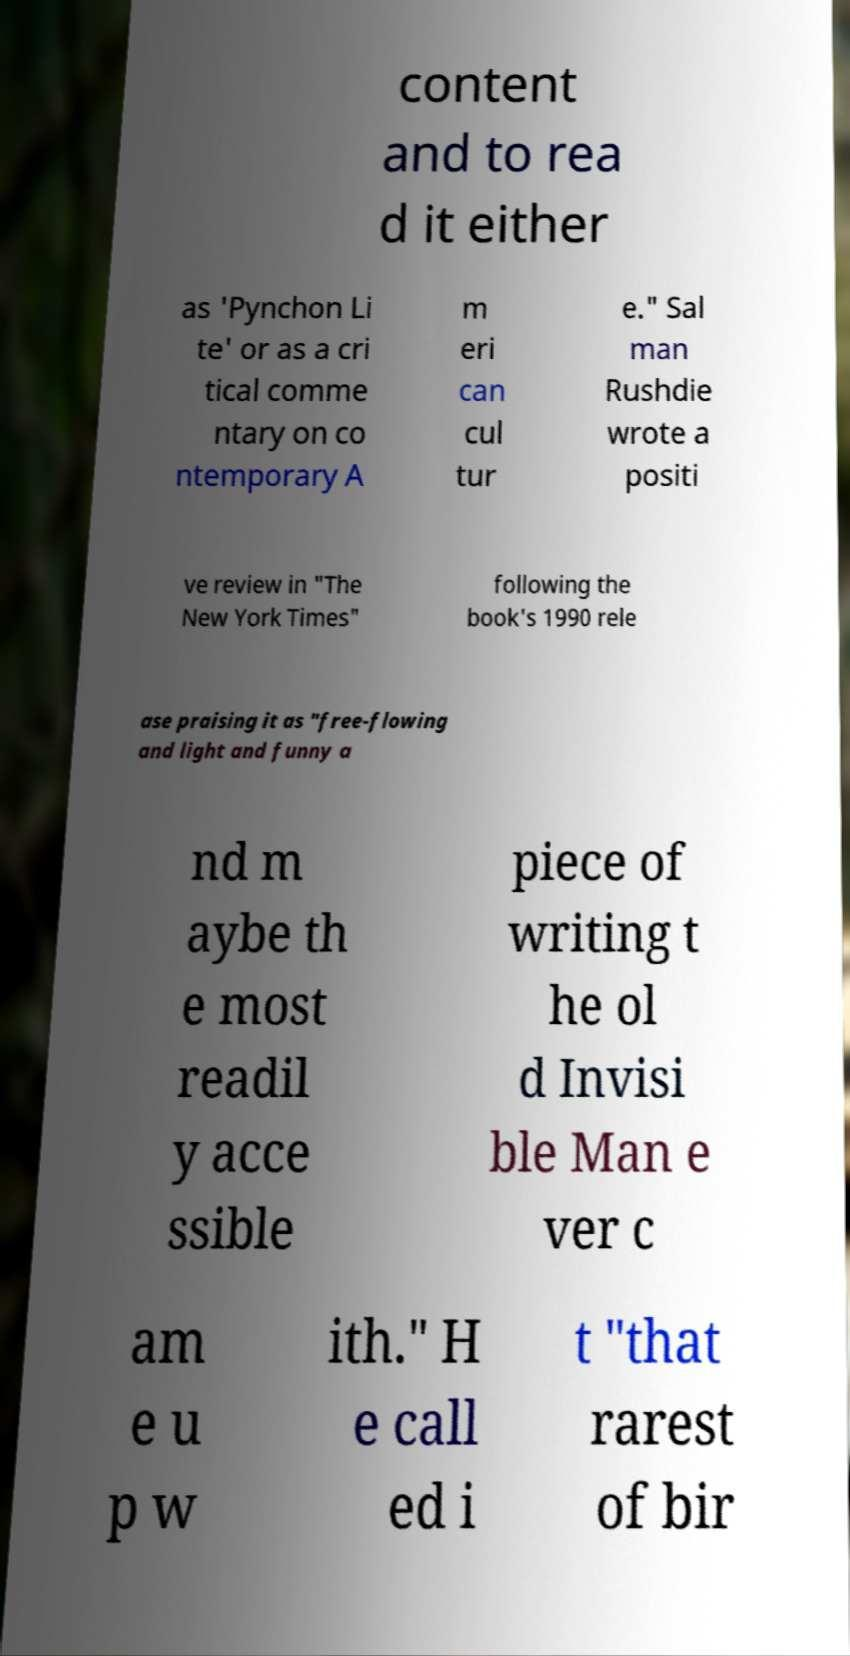For documentation purposes, I need the text within this image transcribed. Could you provide that? content and to rea d it either as 'Pynchon Li te' or as a cri tical comme ntary on co ntemporary A m eri can cul tur e." Sal man Rushdie wrote a positi ve review in "The New York Times" following the book's 1990 rele ase praising it as "free-flowing and light and funny a nd m aybe th e most readil y acce ssible piece of writing t he ol d Invisi ble Man e ver c am e u p w ith." H e call ed i t "that rarest of bir 